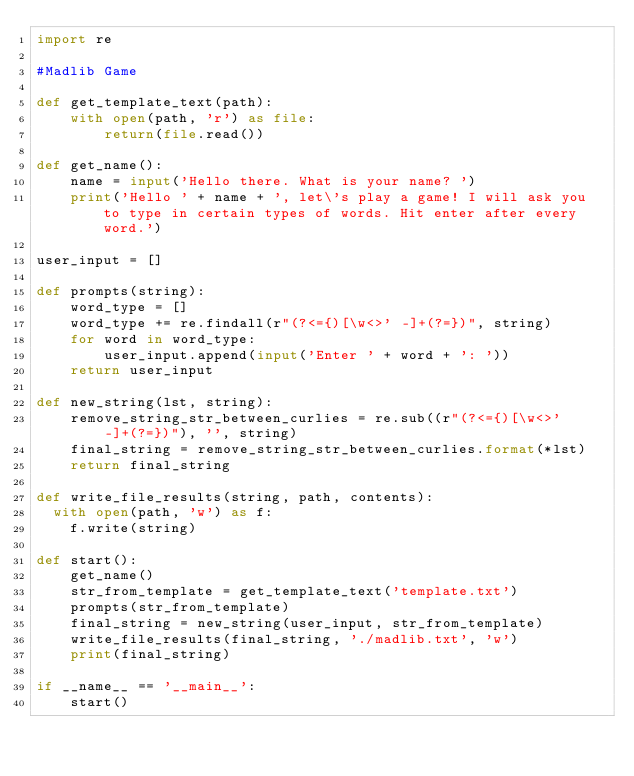<code> <loc_0><loc_0><loc_500><loc_500><_Python_>import re

#Madlib Game

def get_template_text(path):
    with open(path, 'r') as file:
        return(file.read())

def get_name():
    name = input('Hello there. What is your name? ')
    print('Hello ' + name + ', let\'s play a game! I will ask you to type in certain types of words. Hit enter after every word.')

user_input = []

def prompts(string):
    word_type = []
    word_type += re.findall(r"(?<={)[\w<>' -]+(?=})", string)
    for word in word_type:
        user_input.append(input('Enter ' + word + ': '))
    return user_input

def new_string(lst, string):
    remove_string_str_between_curlies = re.sub((r"(?<={)[\w<>' -]+(?=})"), '', string)
    final_string = remove_string_str_between_curlies.format(*lst)
    return final_string

def write_file_results(string, path, contents):
  with open(path, 'w') as f:
    f.write(string)

def start():
    get_name()
    str_from_template = get_template_text('template.txt')
    prompts(str_from_template)
    final_string = new_string(user_input, str_from_template)
    write_file_results(final_string, './madlib.txt', 'w')
    print(final_string)

if __name__ == '__main__':
    start()
</code> 